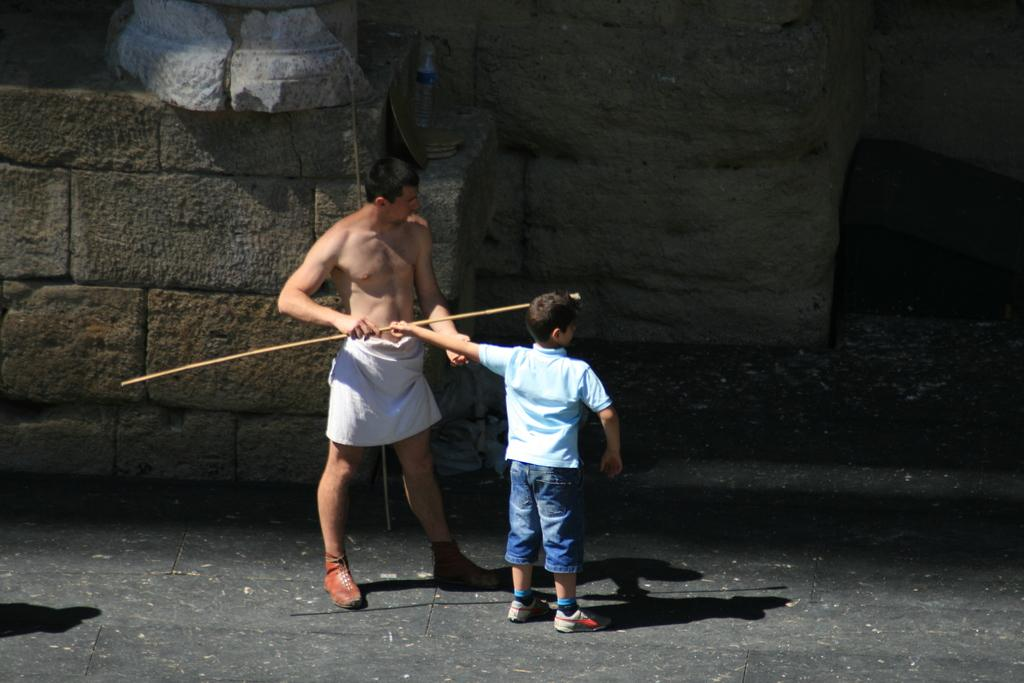What are the main subjects in the image? There are persons standing in the center of the image. What can be seen in the background of the image? There is a wall and a man standing in the background of the image. What is the man in the background holding? The man is holding a stick in his hand. How many eggs are visible in the image? There are no eggs present in the image. What type of test is being conducted in the image? There is no test being conducted in the image. 